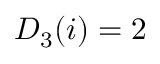<formula> <loc_0><loc_0><loc_500><loc_500>D _ { 3 } ( i ) = 2</formula> 